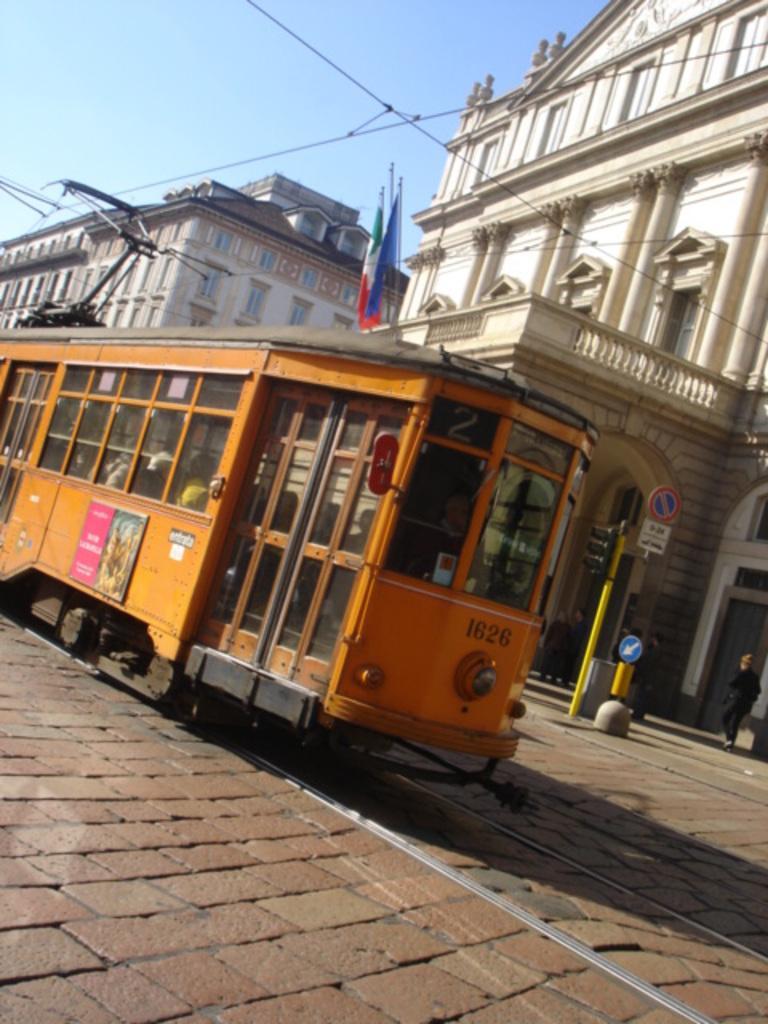How would you summarize this image in a sentence or two? In this picture I can see a train in the middle, in the background there are buildings, flags. There are traffic signals and boards, I can see a person. At the top there is the sky. 